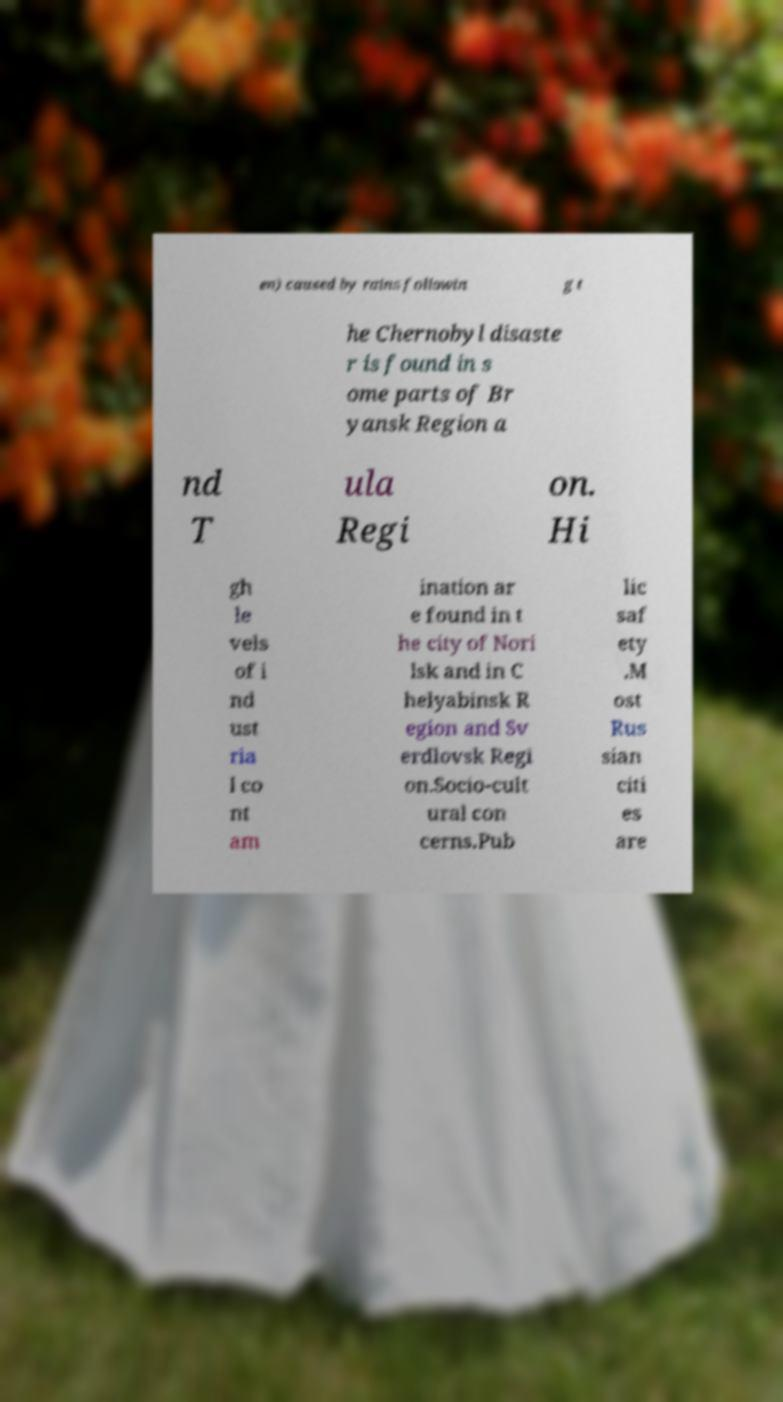Can you read and provide the text displayed in the image?This photo seems to have some interesting text. Can you extract and type it out for me? en) caused by rains followin g t he Chernobyl disaste r is found in s ome parts of Br yansk Region a nd T ula Regi on. Hi gh le vels of i nd ust ria l co nt am ination ar e found in t he city of Nori lsk and in C helyabinsk R egion and Sv erdlovsk Regi on.Socio-cult ural con cerns.Pub lic saf ety .M ost Rus sian citi es are 